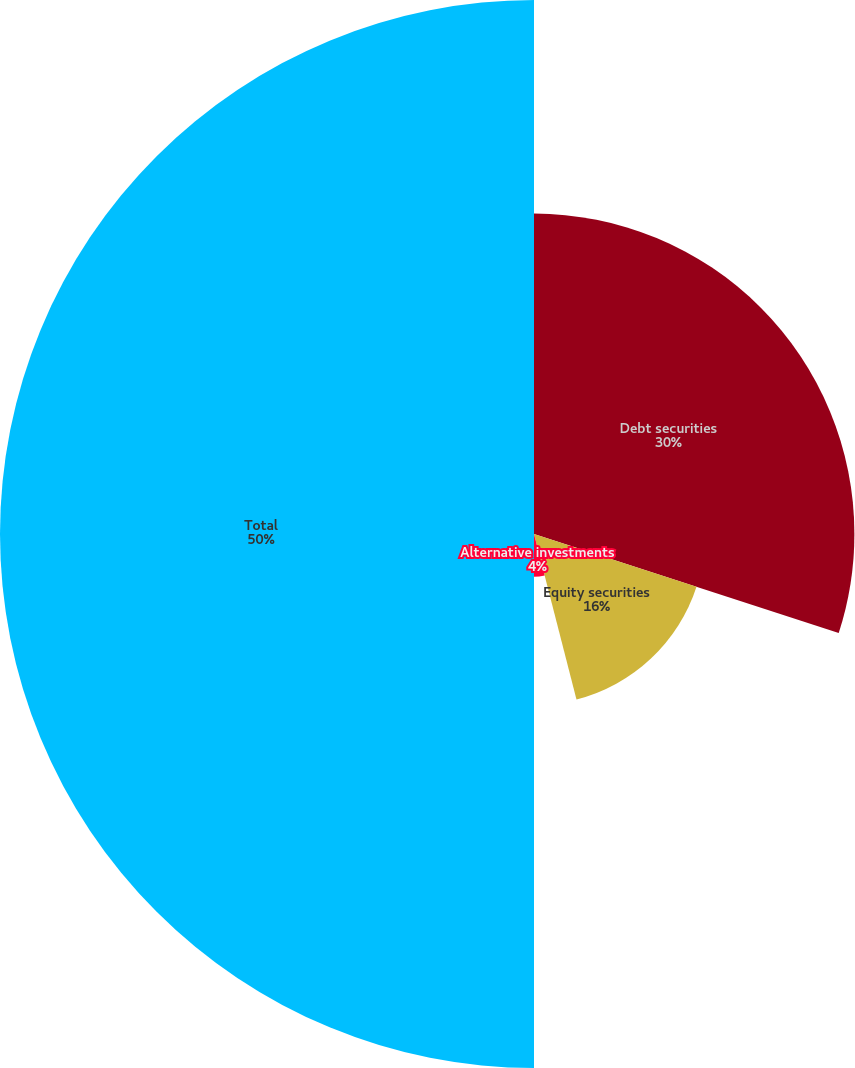<chart> <loc_0><loc_0><loc_500><loc_500><pie_chart><fcel>Debt securities<fcel>Equity securities<fcel>Alternative investments<fcel>Total<nl><fcel>30.0%<fcel>16.0%<fcel>4.0%<fcel>50.0%<nl></chart> 